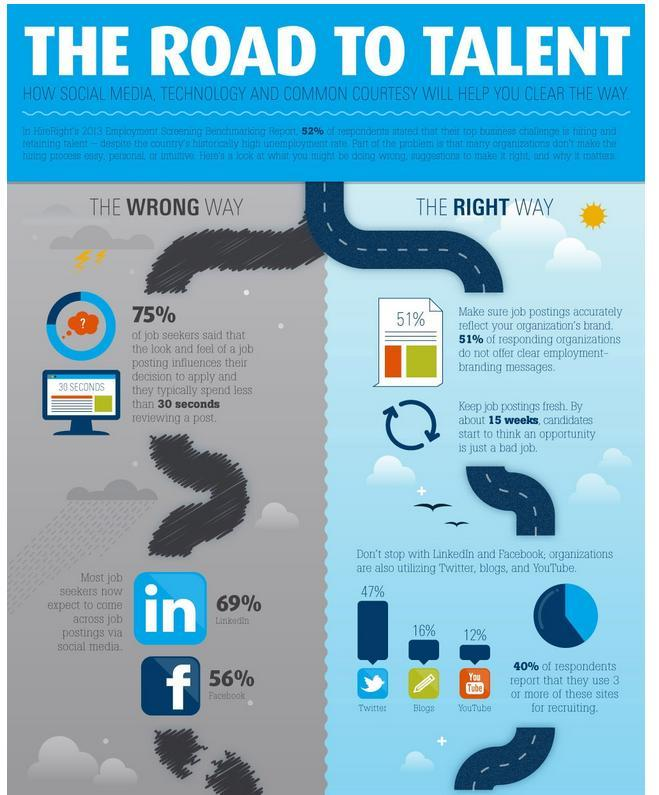What percentage of jobseekers come across job posting through facebook as per the survey?
Answer the question with a short phrase. 56% In which job site, majority of the job seekers come across the job posting according to the survey? Linkedin What percentage of respondents report that they use youtube for recruiting purpose as per the survey? 12% What percentage of respondents report that they use Twitter for recruiting purpose as per the survey? 47% What percentage of respondents report that they use blogs for recruiting purpose as per the survey? 16% 